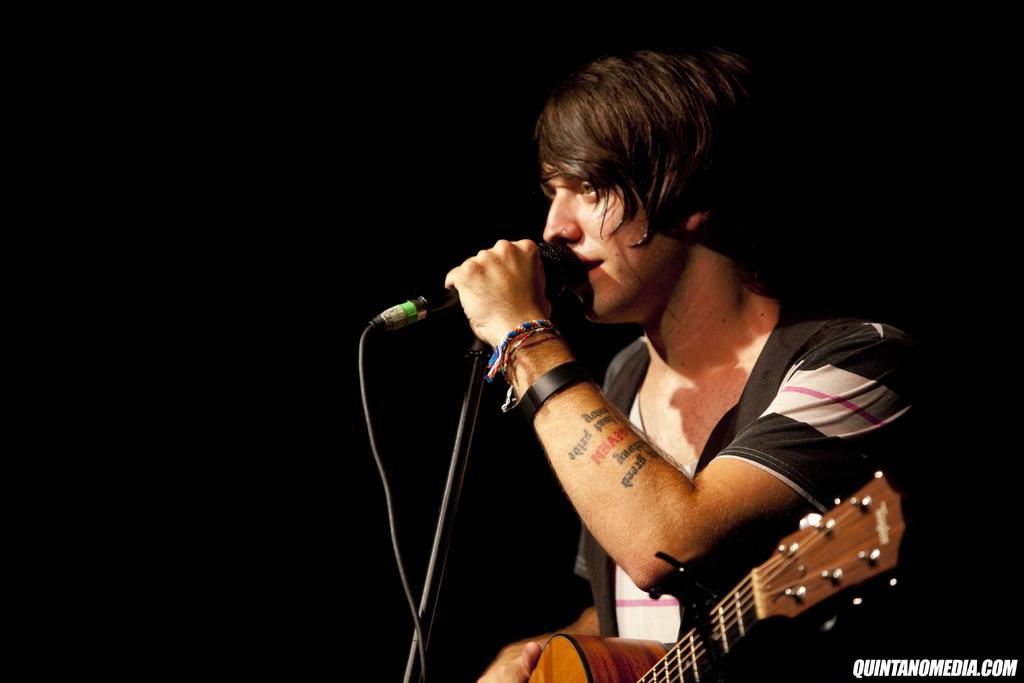Who is the main subject in the image? There is a man in the image. What is the man doing in the image? The man is standing in the image. What is the man holding in his hands? The man is holding a guitar and a microphone in his hands. How many quarters can be seen in the image? There are no quarters present in the image. 